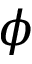Convert formula to latex. <formula><loc_0><loc_0><loc_500><loc_500>\phi</formula> 